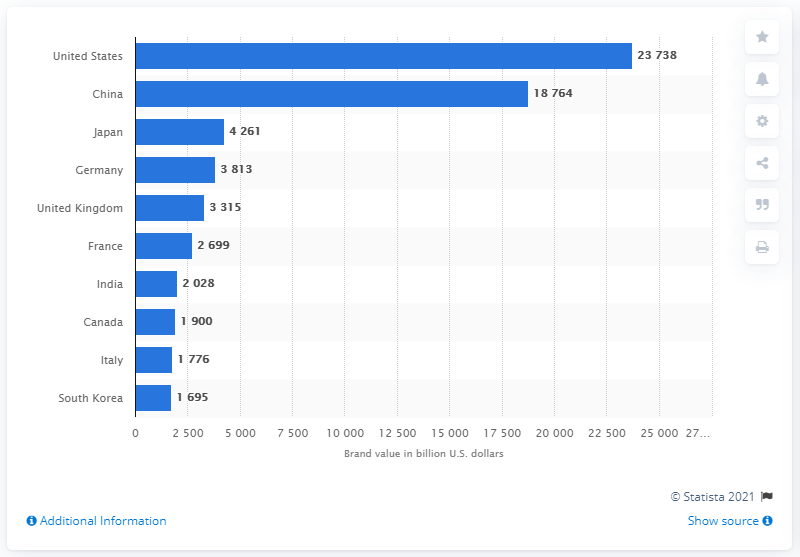Indicate a few pertinent items in this graphic. Many of the world's most valuable brands originate from the United States. The value of the United States in dollars in 2020 was 23,738. In 2020, the value of China was 18,764 in U.S. dollars. 